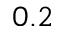Convert formula to latex. <formula><loc_0><loc_0><loc_500><loc_500>0 . 2</formula> 